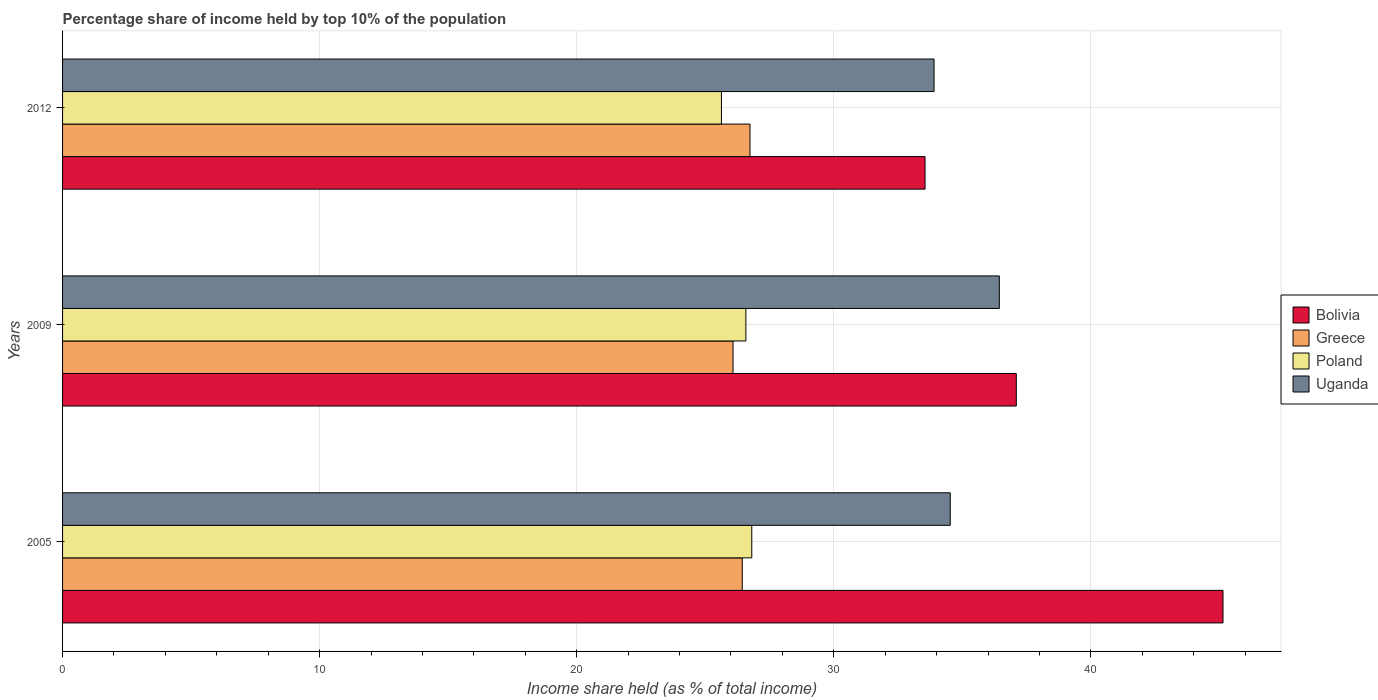How many groups of bars are there?
Offer a terse response. 3. Are the number of bars per tick equal to the number of legend labels?
Make the answer very short. Yes. How many bars are there on the 2nd tick from the top?
Provide a short and direct response. 4. What is the percentage share of income held by top 10% of the population in Poland in 2009?
Offer a very short reply. 26.58. Across all years, what is the maximum percentage share of income held by top 10% of the population in Uganda?
Ensure brevity in your answer.  36.44. Across all years, what is the minimum percentage share of income held by top 10% of the population in Uganda?
Keep it short and to the point. 33.9. In which year was the percentage share of income held by top 10% of the population in Greece maximum?
Offer a very short reply. 2012. In which year was the percentage share of income held by top 10% of the population in Bolivia minimum?
Make the answer very short. 2012. What is the total percentage share of income held by top 10% of the population in Greece in the graph?
Provide a succinct answer. 79.26. What is the difference between the percentage share of income held by top 10% of the population in Greece in 2009 and that in 2012?
Your response must be concise. -0.66. What is the difference between the percentage share of income held by top 10% of the population in Greece in 2009 and the percentage share of income held by top 10% of the population in Uganda in 2012?
Your answer should be very brief. -7.82. What is the average percentage share of income held by top 10% of the population in Bolivia per year?
Your answer should be compact. 38.6. In the year 2012, what is the difference between the percentage share of income held by top 10% of the population in Greece and percentage share of income held by top 10% of the population in Poland?
Offer a terse response. 1.11. What is the ratio of the percentage share of income held by top 10% of the population in Poland in 2005 to that in 2009?
Your answer should be very brief. 1.01. Is the percentage share of income held by top 10% of the population in Bolivia in 2005 less than that in 2012?
Your answer should be compact. No. What is the difference between the highest and the second highest percentage share of income held by top 10% of the population in Uganda?
Your answer should be very brief. 1.91. What is the difference between the highest and the lowest percentage share of income held by top 10% of the population in Bolivia?
Offer a very short reply. 11.59. Is the sum of the percentage share of income held by top 10% of the population in Uganda in 2009 and 2012 greater than the maximum percentage share of income held by top 10% of the population in Greece across all years?
Provide a short and direct response. Yes. Is it the case that in every year, the sum of the percentage share of income held by top 10% of the population in Greece and percentage share of income held by top 10% of the population in Uganda is greater than the sum of percentage share of income held by top 10% of the population in Poland and percentage share of income held by top 10% of the population in Bolivia?
Make the answer very short. Yes. What does the 1st bar from the bottom in 2005 represents?
Your answer should be very brief. Bolivia. How many years are there in the graph?
Ensure brevity in your answer.  3. Are the values on the major ticks of X-axis written in scientific E-notation?
Offer a very short reply. No. Where does the legend appear in the graph?
Offer a terse response. Center right. How many legend labels are there?
Keep it short and to the point. 4. What is the title of the graph?
Your answer should be compact. Percentage share of income held by top 10% of the population. Does "Seychelles" appear as one of the legend labels in the graph?
Offer a terse response. No. What is the label or title of the X-axis?
Your answer should be very brief. Income share held (as % of total income). What is the label or title of the Y-axis?
Your answer should be compact. Years. What is the Income share held (as % of total income) in Bolivia in 2005?
Provide a short and direct response. 45.14. What is the Income share held (as % of total income) of Greece in 2005?
Your answer should be very brief. 26.44. What is the Income share held (as % of total income) in Poland in 2005?
Your answer should be compact. 26.81. What is the Income share held (as % of total income) of Uganda in 2005?
Your answer should be very brief. 34.53. What is the Income share held (as % of total income) of Bolivia in 2009?
Provide a short and direct response. 37.1. What is the Income share held (as % of total income) in Greece in 2009?
Provide a succinct answer. 26.08. What is the Income share held (as % of total income) of Poland in 2009?
Keep it short and to the point. 26.58. What is the Income share held (as % of total income) in Uganda in 2009?
Your response must be concise. 36.44. What is the Income share held (as % of total income) of Bolivia in 2012?
Ensure brevity in your answer.  33.55. What is the Income share held (as % of total income) of Greece in 2012?
Provide a succinct answer. 26.74. What is the Income share held (as % of total income) in Poland in 2012?
Offer a very short reply. 25.63. What is the Income share held (as % of total income) in Uganda in 2012?
Keep it short and to the point. 33.9. Across all years, what is the maximum Income share held (as % of total income) in Bolivia?
Give a very brief answer. 45.14. Across all years, what is the maximum Income share held (as % of total income) in Greece?
Your response must be concise. 26.74. Across all years, what is the maximum Income share held (as % of total income) of Poland?
Ensure brevity in your answer.  26.81. Across all years, what is the maximum Income share held (as % of total income) in Uganda?
Offer a terse response. 36.44. Across all years, what is the minimum Income share held (as % of total income) in Bolivia?
Give a very brief answer. 33.55. Across all years, what is the minimum Income share held (as % of total income) in Greece?
Your answer should be very brief. 26.08. Across all years, what is the minimum Income share held (as % of total income) in Poland?
Your answer should be very brief. 25.63. Across all years, what is the minimum Income share held (as % of total income) in Uganda?
Make the answer very short. 33.9. What is the total Income share held (as % of total income) of Bolivia in the graph?
Offer a terse response. 115.79. What is the total Income share held (as % of total income) of Greece in the graph?
Your response must be concise. 79.26. What is the total Income share held (as % of total income) in Poland in the graph?
Give a very brief answer. 79.02. What is the total Income share held (as % of total income) in Uganda in the graph?
Provide a succinct answer. 104.87. What is the difference between the Income share held (as % of total income) in Bolivia in 2005 and that in 2009?
Your answer should be compact. 8.04. What is the difference between the Income share held (as % of total income) of Greece in 2005 and that in 2009?
Your answer should be compact. 0.36. What is the difference between the Income share held (as % of total income) of Poland in 2005 and that in 2009?
Your answer should be very brief. 0.23. What is the difference between the Income share held (as % of total income) in Uganda in 2005 and that in 2009?
Your answer should be very brief. -1.91. What is the difference between the Income share held (as % of total income) in Bolivia in 2005 and that in 2012?
Your response must be concise. 11.59. What is the difference between the Income share held (as % of total income) in Greece in 2005 and that in 2012?
Your response must be concise. -0.3. What is the difference between the Income share held (as % of total income) of Poland in 2005 and that in 2012?
Offer a terse response. 1.18. What is the difference between the Income share held (as % of total income) in Uganda in 2005 and that in 2012?
Make the answer very short. 0.63. What is the difference between the Income share held (as % of total income) in Bolivia in 2009 and that in 2012?
Provide a succinct answer. 3.55. What is the difference between the Income share held (as % of total income) of Greece in 2009 and that in 2012?
Give a very brief answer. -0.66. What is the difference between the Income share held (as % of total income) in Poland in 2009 and that in 2012?
Offer a very short reply. 0.95. What is the difference between the Income share held (as % of total income) of Uganda in 2009 and that in 2012?
Your response must be concise. 2.54. What is the difference between the Income share held (as % of total income) in Bolivia in 2005 and the Income share held (as % of total income) in Greece in 2009?
Your response must be concise. 19.06. What is the difference between the Income share held (as % of total income) of Bolivia in 2005 and the Income share held (as % of total income) of Poland in 2009?
Your response must be concise. 18.56. What is the difference between the Income share held (as % of total income) of Bolivia in 2005 and the Income share held (as % of total income) of Uganda in 2009?
Your answer should be very brief. 8.7. What is the difference between the Income share held (as % of total income) of Greece in 2005 and the Income share held (as % of total income) of Poland in 2009?
Offer a terse response. -0.14. What is the difference between the Income share held (as % of total income) of Poland in 2005 and the Income share held (as % of total income) of Uganda in 2009?
Provide a short and direct response. -9.63. What is the difference between the Income share held (as % of total income) of Bolivia in 2005 and the Income share held (as % of total income) of Poland in 2012?
Provide a short and direct response. 19.51. What is the difference between the Income share held (as % of total income) in Bolivia in 2005 and the Income share held (as % of total income) in Uganda in 2012?
Your answer should be compact. 11.24. What is the difference between the Income share held (as % of total income) in Greece in 2005 and the Income share held (as % of total income) in Poland in 2012?
Give a very brief answer. 0.81. What is the difference between the Income share held (as % of total income) of Greece in 2005 and the Income share held (as % of total income) of Uganda in 2012?
Provide a succinct answer. -7.46. What is the difference between the Income share held (as % of total income) in Poland in 2005 and the Income share held (as % of total income) in Uganda in 2012?
Your response must be concise. -7.09. What is the difference between the Income share held (as % of total income) in Bolivia in 2009 and the Income share held (as % of total income) in Greece in 2012?
Keep it short and to the point. 10.36. What is the difference between the Income share held (as % of total income) of Bolivia in 2009 and the Income share held (as % of total income) of Poland in 2012?
Give a very brief answer. 11.47. What is the difference between the Income share held (as % of total income) of Greece in 2009 and the Income share held (as % of total income) of Poland in 2012?
Offer a very short reply. 0.45. What is the difference between the Income share held (as % of total income) of Greece in 2009 and the Income share held (as % of total income) of Uganda in 2012?
Your answer should be compact. -7.82. What is the difference between the Income share held (as % of total income) in Poland in 2009 and the Income share held (as % of total income) in Uganda in 2012?
Offer a terse response. -7.32. What is the average Income share held (as % of total income) of Bolivia per year?
Give a very brief answer. 38.6. What is the average Income share held (as % of total income) in Greece per year?
Your answer should be very brief. 26.42. What is the average Income share held (as % of total income) of Poland per year?
Give a very brief answer. 26.34. What is the average Income share held (as % of total income) in Uganda per year?
Your response must be concise. 34.96. In the year 2005, what is the difference between the Income share held (as % of total income) of Bolivia and Income share held (as % of total income) of Greece?
Keep it short and to the point. 18.7. In the year 2005, what is the difference between the Income share held (as % of total income) in Bolivia and Income share held (as % of total income) in Poland?
Your answer should be compact. 18.33. In the year 2005, what is the difference between the Income share held (as % of total income) of Bolivia and Income share held (as % of total income) of Uganda?
Offer a terse response. 10.61. In the year 2005, what is the difference between the Income share held (as % of total income) in Greece and Income share held (as % of total income) in Poland?
Keep it short and to the point. -0.37. In the year 2005, what is the difference between the Income share held (as % of total income) of Greece and Income share held (as % of total income) of Uganda?
Give a very brief answer. -8.09. In the year 2005, what is the difference between the Income share held (as % of total income) in Poland and Income share held (as % of total income) in Uganda?
Your answer should be very brief. -7.72. In the year 2009, what is the difference between the Income share held (as % of total income) of Bolivia and Income share held (as % of total income) of Greece?
Offer a terse response. 11.02. In the year 2009, what is the difference between the Income share held (as % of total income) of Bolivia and Income share held (as % of total income) of Poland?
Ensure brevity in your answer.  10.52. In the year 2009, what is the difference between the Income share held (as % of total income) of Bolivia and Income share held (as % of total income) of Uganda?
Give a very brief answer. 0.66. In the year 2009, what is the difference between the Income share held (as % of total income) of Greece and Income share held (as % of total income) of Poland?
Your answer should be compact. -0.5. In the year 2009, what is the difference between the Income share held (as % of total income) in Greece and Income share held (as % of total income) in Uganda?
Offer a terse response. -10.36. In the year 2009, what is the difference between the Income share held (as % of total income) of Poland and Income share held (as % of total income) of Uganda?
Give a very brief answer. -9.86. In the year 2012, what is the difference between the Income share held (as % of total income) of Bolivia and Income share held (as % of total income) of Greece?
Give a very brief answer. 6.81. In the year 2012, what is the difference between the Income share held (as % of total income) of Bolivia and Income share held (as % of total income) of Poland?
Provide a succinct answer. 7.92. In the year 2012, what is the difference between the Income share held (as % of total income) of Bolivia and Income share held (as % of total income) of Uganda?
Your response must be concise. -0.35. In the year 2012, what is the difference between the Income share held (as % of total income) of Greece and Income share held (as % of total income) of Poland?
Your answer should be compact. 1.11. In the year 2012, what is the difference between the Income share held (as % of total income) in Greece and Income share held (as % of total income) in Uganda?
Ensure brevity in your answer.  -7.16. In the year 2012, what is the difference between the Income share held (as % of total income) of Poland and Income share held (as % of total income) of Uganda?
Make the answer very short. -8.27. What is the ratio of the Income share held (as % of total income) of Bolivia in 2005 to that in 2009?
Keep it short and to the point. 1.22. What is the ratio of the Income share held (as % of total income) in Greece in 2005 to that in 2009?
Your answer should be compact. 1.01. What is the ratio of the Income share held (as % of total income) in Poland in 2005 to that in 2009?
Make the answer very short. 1.01. What is the ratio of the Income share held (as % of total income) in Uganda in 2005 to that in 2009?
Your response must be concise. 0.95. What is the ratio of the Income share held (as % of total income) of Bolivia in 2005 to that in 2012?
Keep it short and to the point. 1.35. What is the ratio of the Income share held (as % of total income) in Poland in 2005 to that in 2012?
Provide a short and direct response. 1.05. What is the ratio of the Income share held (as % of total income) in Uganda in 2005 to that in 2012?
Give a very brief answer. 1.02. What is the ratio of the Income share held (as % of total income) in Bolivia in 2009 to that in 2012?
Offer a terse response. 1.11. What is the ratio of the Income share held (as % of total income) of Greece in 2009 to that in 2012?
Your answer should be compact. 0.98. What is the ratio of the Income share held (as % of total income) of Poland in 2009 to that in 2012?
Provide a short and direct response. 1.04. What is the ratio of the Income share held (as % of total income) of Uganda in 2009 to that in 2012?
Your answer should be compact. 1.07. What is the difference between the highest and the second highest Income share held (as % of total income) of Bolivia?
Provide a short and direct response. 8.04. What is the difference between the highest and the second highest Income share held (as % of total income) in Greece?
Ensure brevity in your answer.  0.3. What is the difference between the highest and the second highest Income share held (as % of total income) in Poland?
Offer a terse response. 0.23. What is the difference between the highest and the second highest Income share held (as % of total income) in Uganda?
Your answer should be compact. 1.91. What is the difference between the highest and the lowest Income share held (as % of total income) in Bolivia?
Your response must be concise. 11.59. What is the difference between the highest and the lowest Income share held (as % of total income) of Greece?
Your response must be concise. 0.66. What is the difference between the highest and the lowest Income share held (as % of total income) of Poland?
Offer a terse response. 1.18. What is the difference between the highest and the lowest Income share held (as % of total income) of Uganda?
Your answer should be very brief. 2.54. 